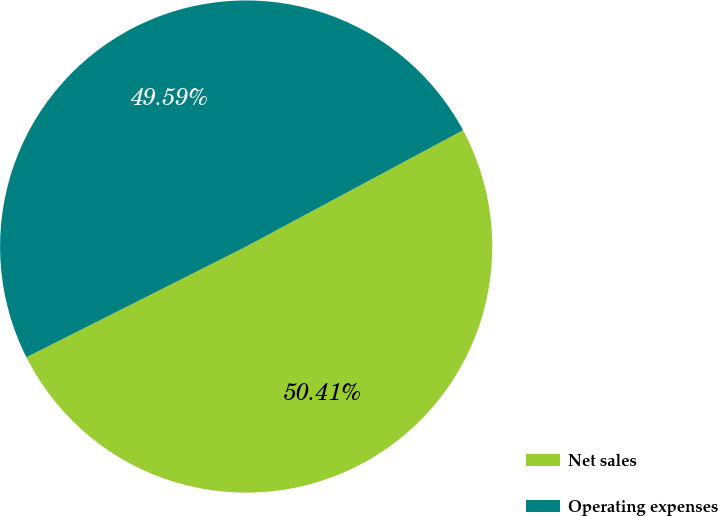Convert chart to OTSL. <chart><loc_0><loc_0><loc_500><loc_500><pie_chart><fcel>Net sales<fcel>Operating expenses<nl><fcel>50.41%<fcel>49.59%<nl></chart> 